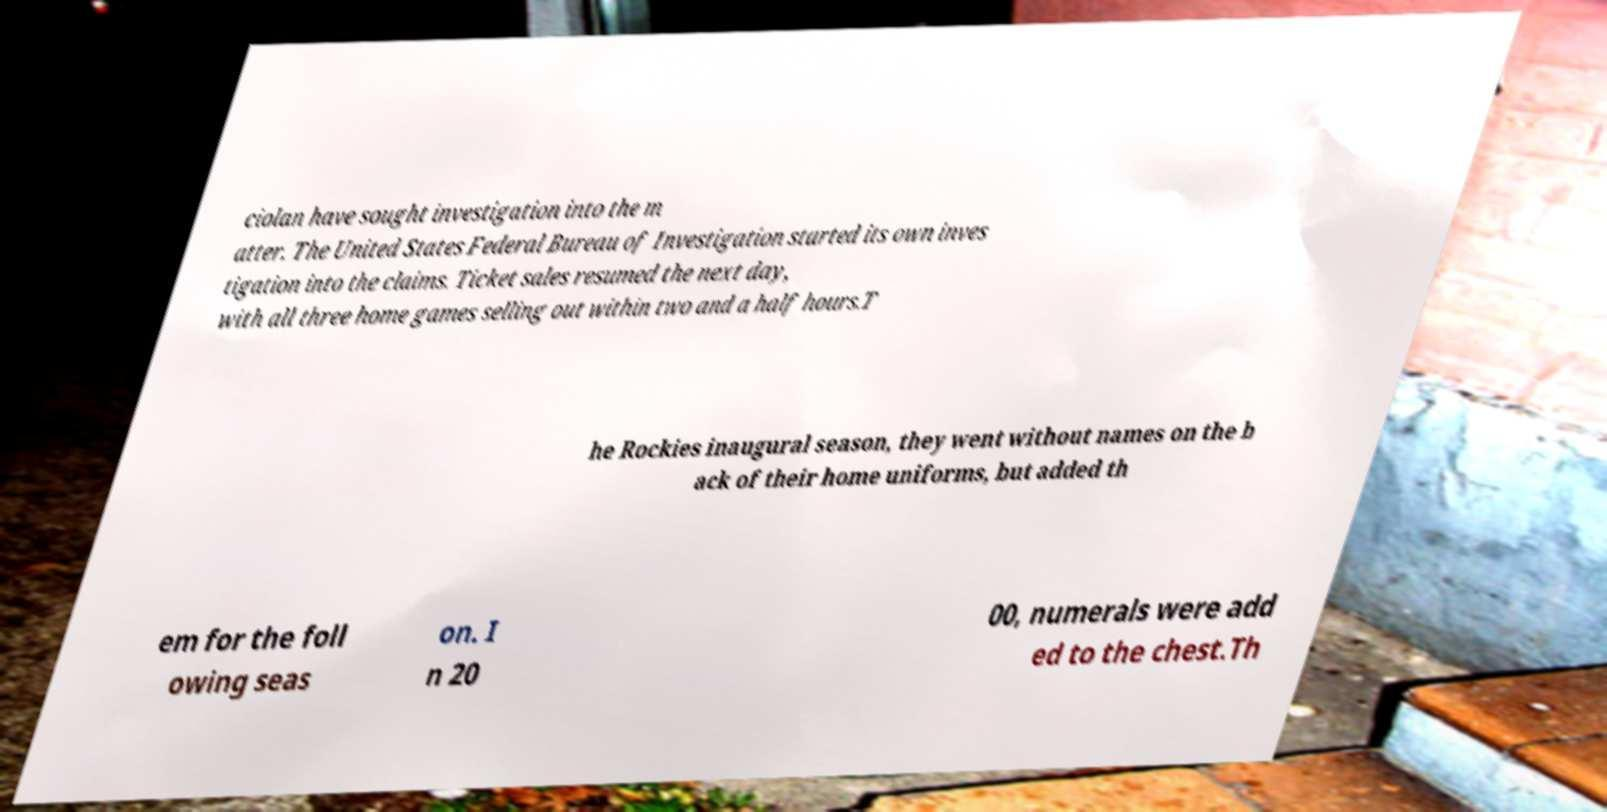Could you extract and type out the text from this image? ciolan have sought investigation into the m atter. The United States Federal Bureau of Investigation started its own inves tigation into the claims. Ticket sales resumed the next day, with all three home games selling out within two and a half hours.T he Rockies inaugural season, they went without names on the b ack of their home uniforms, but added th em for the foll owing seas on. I n 20 00, numerals were add ed to the chest.Th 